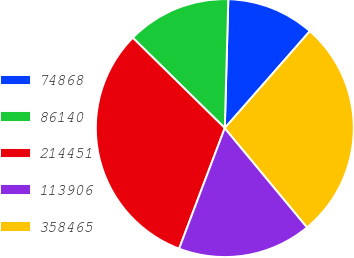Convert chart to OTSL. <chart><loc_0><loc_0><loc_500><loc_500><pie_chart><fcel>74868<fcel>86140<fcel>214451<fcel>113906<fcel>358465<nl><fcel>11.03%<fcel>13.08%<fcel>31.59%<fcel>16.78%<fcel>27.52%<nl></chart> 